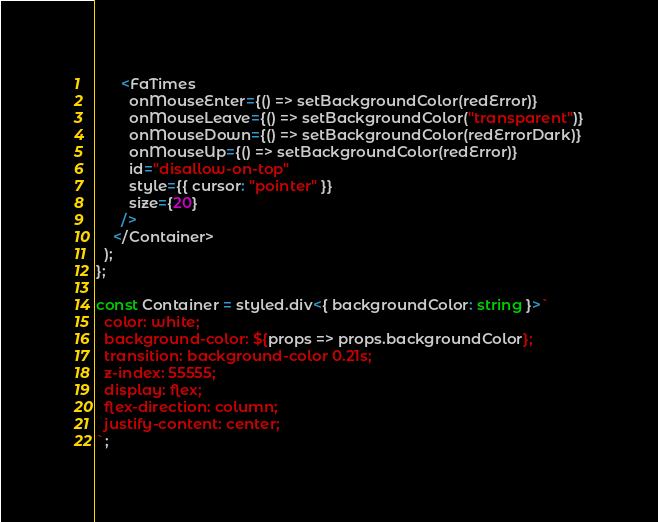<code> <loc_0><loc_0><loc_500><loc_500><_TypeScript_>      <FaTimes
        onMouseEnter={() => setBackgroundColor(redError)}
        onMouseLeave={() => setBackgroundColor("transparent")}
        onMouseDown={() => setBackgroundColor(redErrorDark)}
        onMouseUp={() => setBackgroundColor(redError)}
        id="disallow-on-top"
        style={{ cursor: "pointer" }}
        size={20}
      />
    </Container>
  );
};

const Container = styled.div<{ backgroundColor: string }>`
  color: white;
  background-color: ${props => props.backgroundColor};
  transition: background-color 0.21s;
  z-index: 55555;
  display: flex;
  flex-direction: column;
  justify-content: center;
`;
</code> 